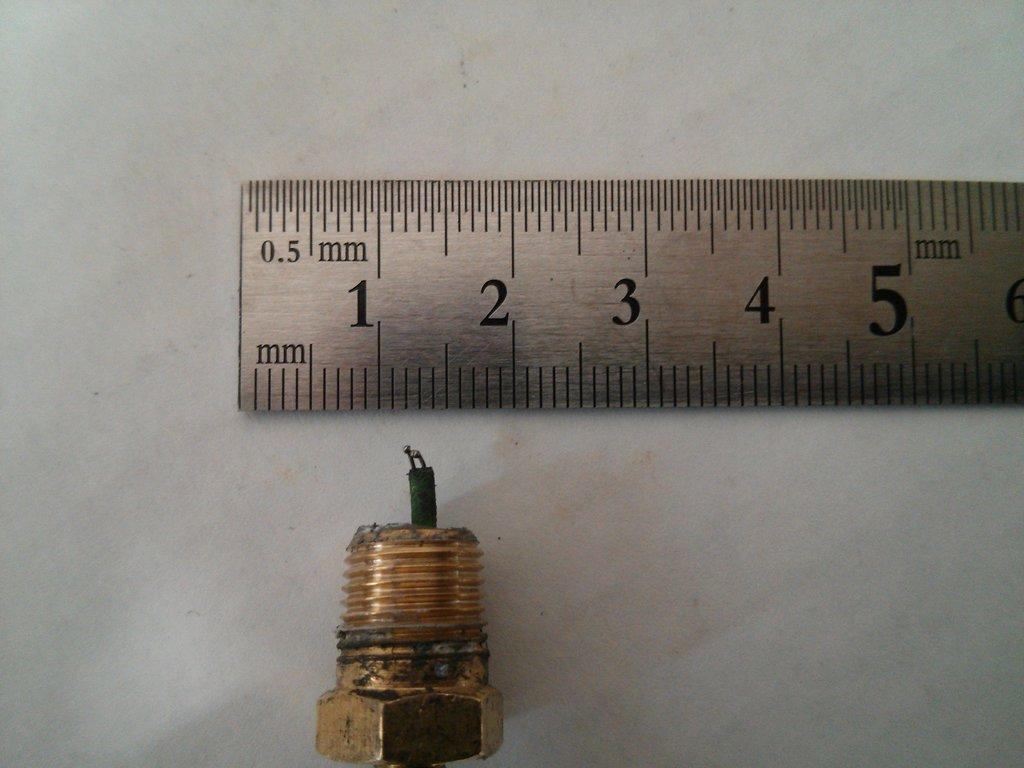<image>
Give a short and clear explanation of the subsequent image. A metal ruler showing the scale of a bolt and wire. 